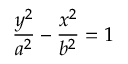Convert formula to latex. <formula><loc_0><loc_0><loc_500><loc_500>{ \frac { y ^ { 2 } } { a ^ { 2 } } } - { \frac { x ^ { 2 } } { b ^ { 2 } } } = 1</formula> 